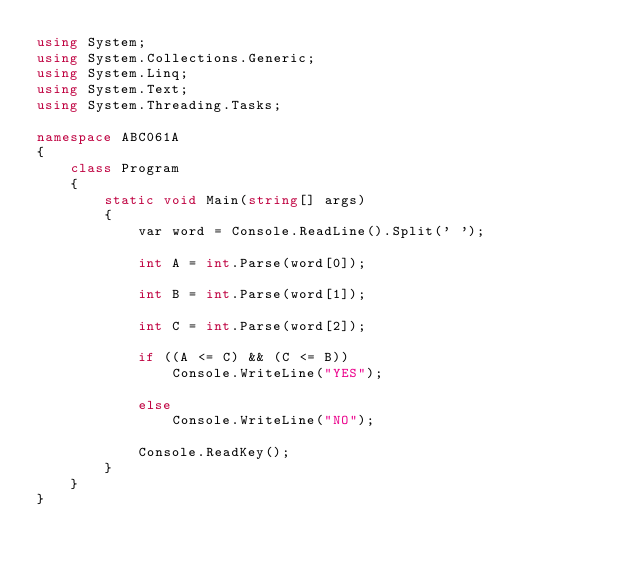Convert code to text. <code><loc_0><loc_0><loc_500><loc_500><_C#_>using System;
using System.Collections.Generic;
using System.Linq;
using System.Text;
using System.Threading.Tasks;

namespace ABC061A
{
    class Program
    {
        static void Main(string[] args)
        {
            var word = Console.ReadLine().Split(' ');

            int A = int.Parse(word[0]);

            int B = int.Parse(word[1]);

            int C = int.Parse(word[2]);

            if ((A <= C) && (C <= B))
                Console.WriteLine("YES");

            else
                Console.WriteLine("NO");

            Console.ReadKey();
        }
    }
}
</code> 